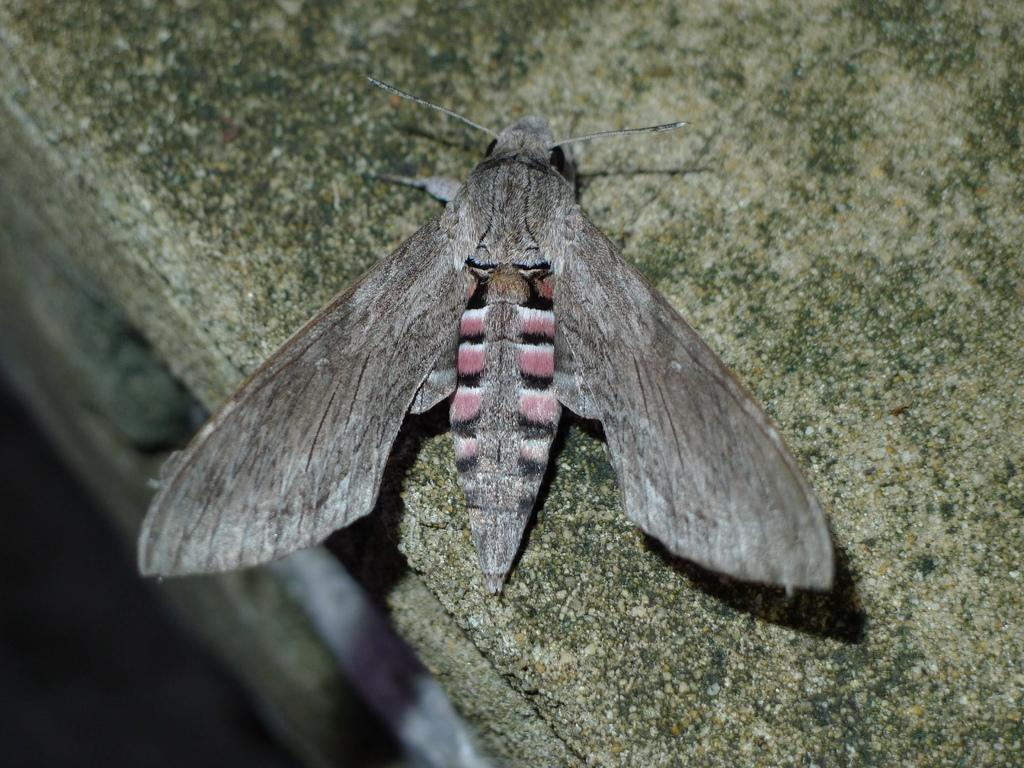What type of creature can be seen in the image? There is an insect in the image. Where is the insect located? The insect is on a platform. What type of police vehicle can be seen in the image? There is no police vehicle present in the image; it only features an insect on a platform. 